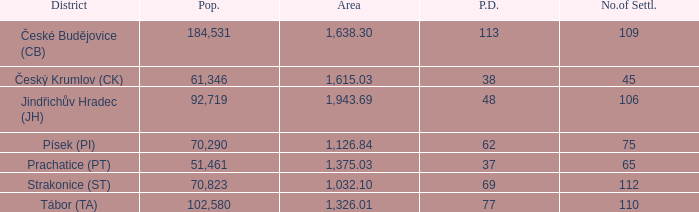How many settlements are in český krumlov (ck) with a population density higher than 38? None. 